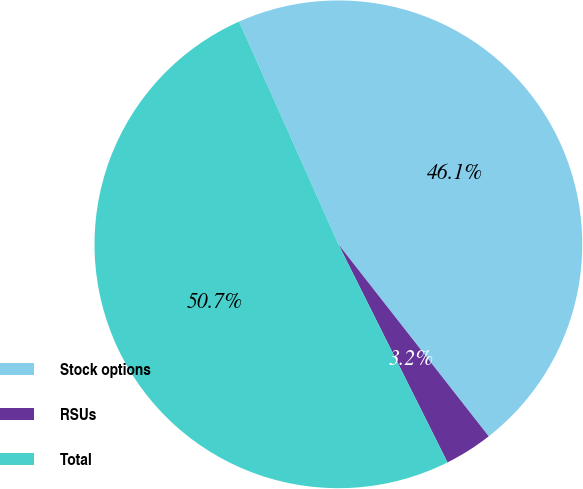Convert chart to OTSL. <chart><loc_0><loc_0><loc_500><loc_500><pie_chart><fcel>Stock options<fcel>RSUs<fcel>Total<nl><fcel>46.1%<fcel>3.19%<fcel>50.71%<nl></chart> 